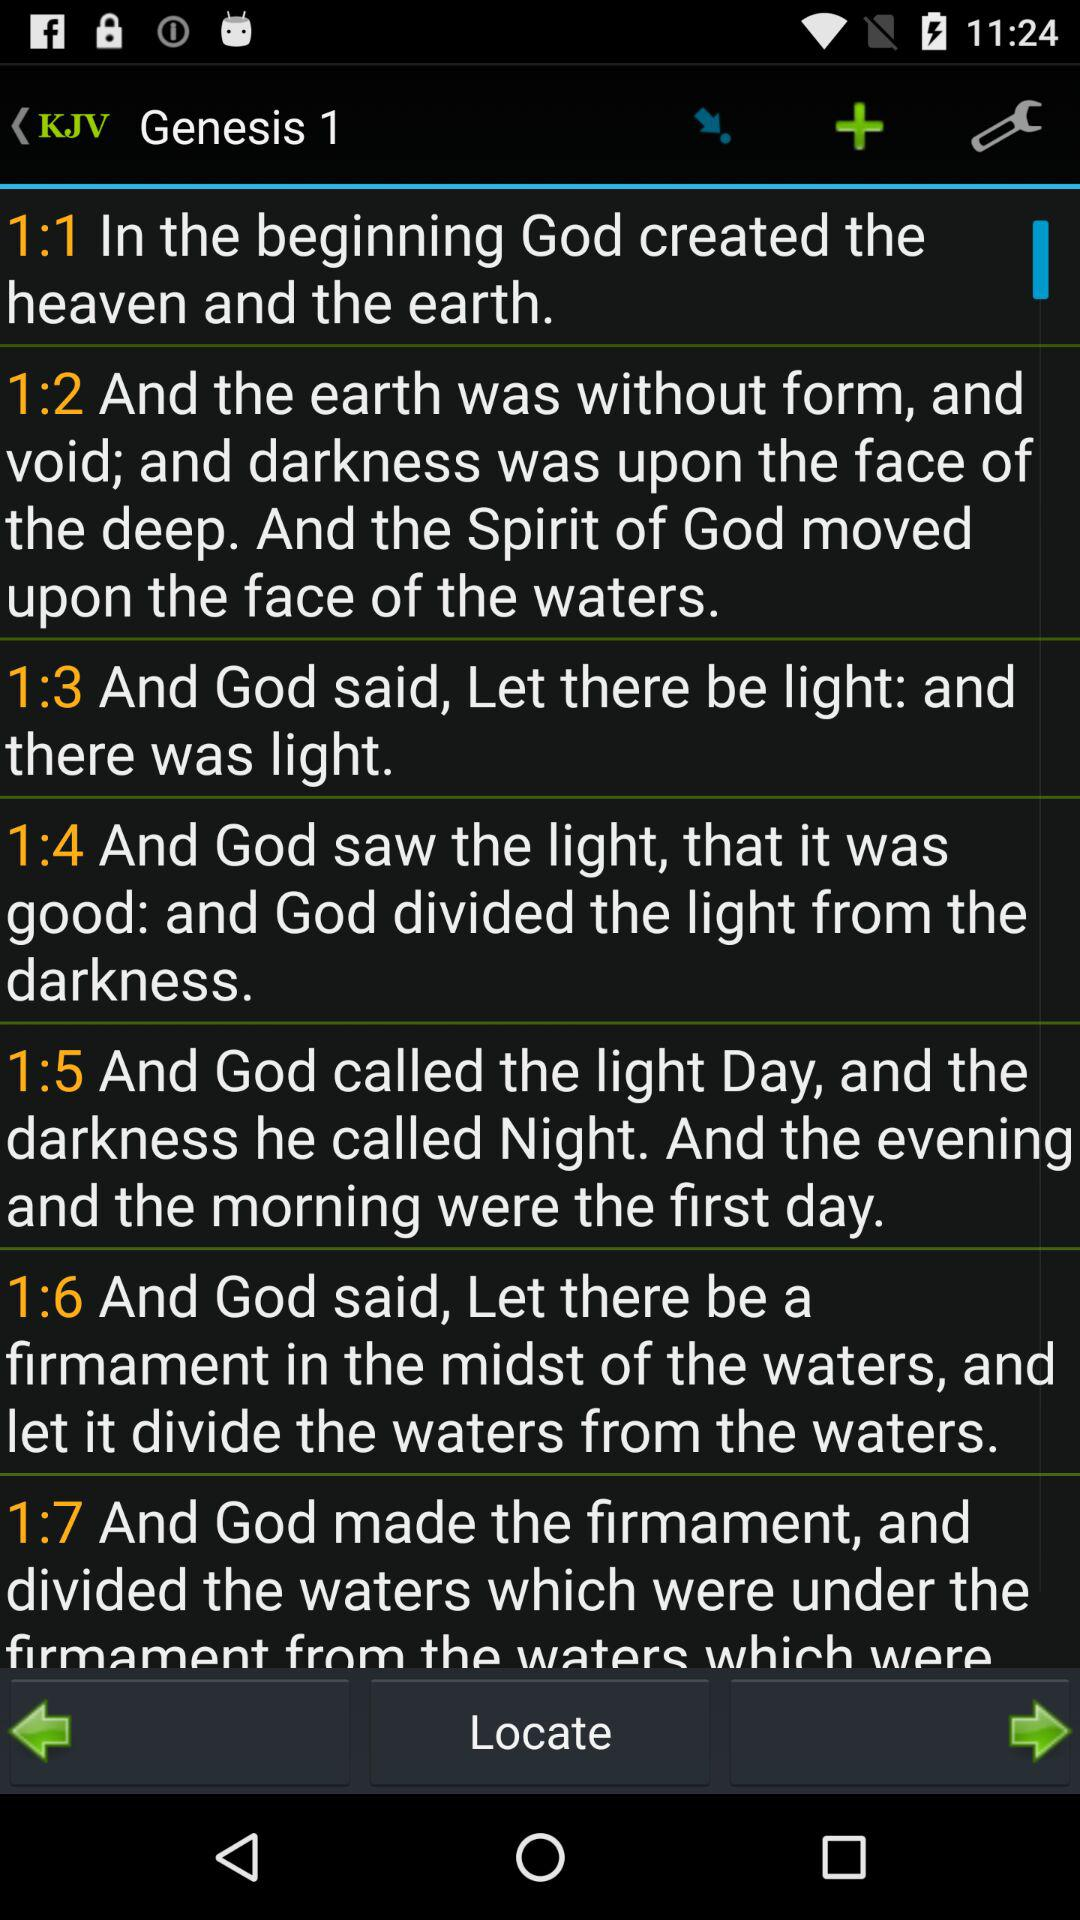Who created the heaven and the earth? The heaven and the earth were created by God. 